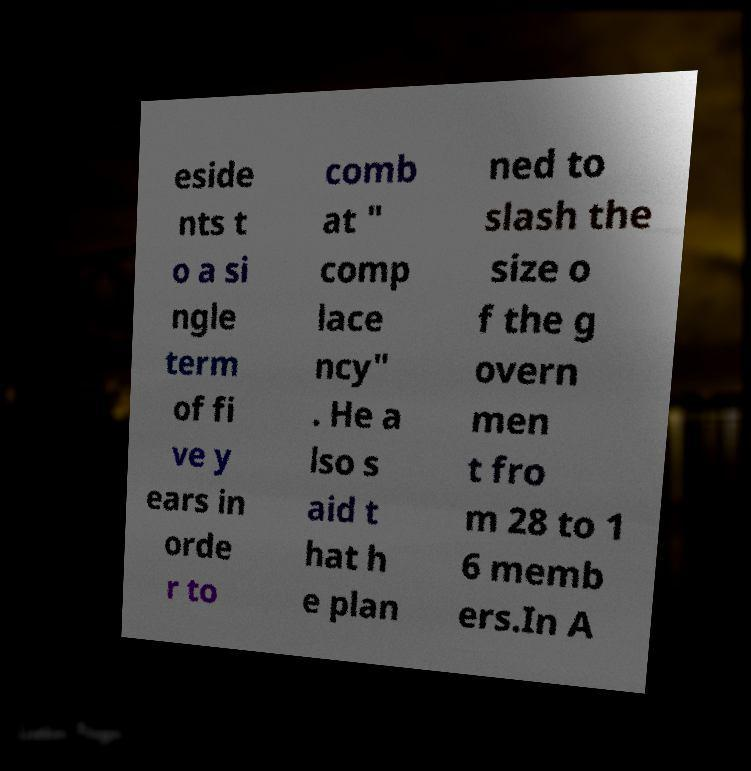I need the written content from this picture converted into text. Can you do that? eside nts t o a si ngle term of fi ve y ears in orde r to comb at " comp lace ncy" . He a lso s aid t hat h e plan ned to slash the size o f the g overn men t fro m 28 to 1 6 memb ers.In A 